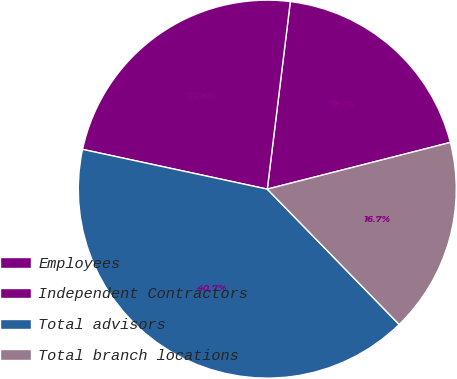Convert chart. <chart><loc_0><loc_0><loc_500><loc_500><pie_chart><fcel>Employees<fcel>Independent Contractors<fcel>Total advisors<fcel>Total branch locations<nl><fcel>19.08%<fcel>23.57%<fcel>40.67%<fcel>16.68%<nl></chart> 